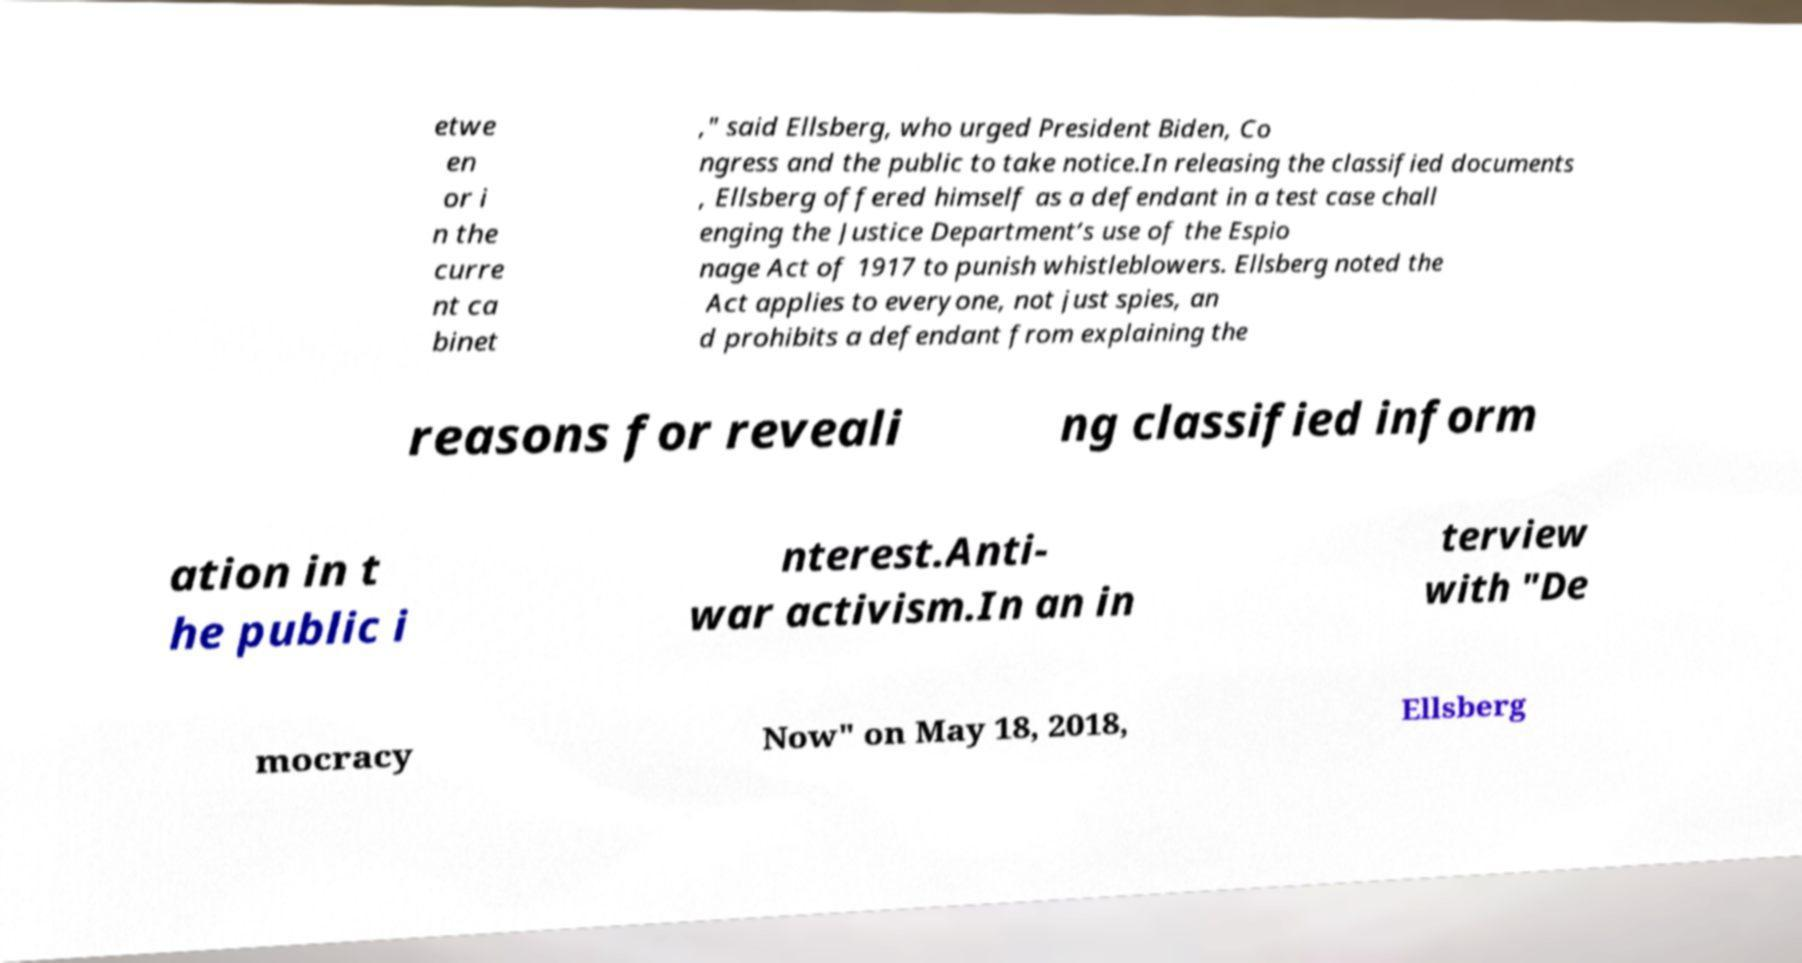For documentation purposes, I need the text within this image transcribed. Could you provide that? etwe en or i n the curre nt ca binet ," said Ellsberg, who urged President Biden, Co ngress and the public to take notice.In releasing the classified documents , Ellsberg offered himself as a defendant in a test case chall enging the Justice Department’s use of the Espio nage Act of 1917 to punish whistleblowers. Ellsberg noted the Act applies to everyone, not just spies, an d prohibits a defendant from explaining the reasons for reveali ng classified inform ation in t he public i nterest.Anti- war activism.In an in terview with "De mocracy Now" on May 18, 2018, Ellsberg 